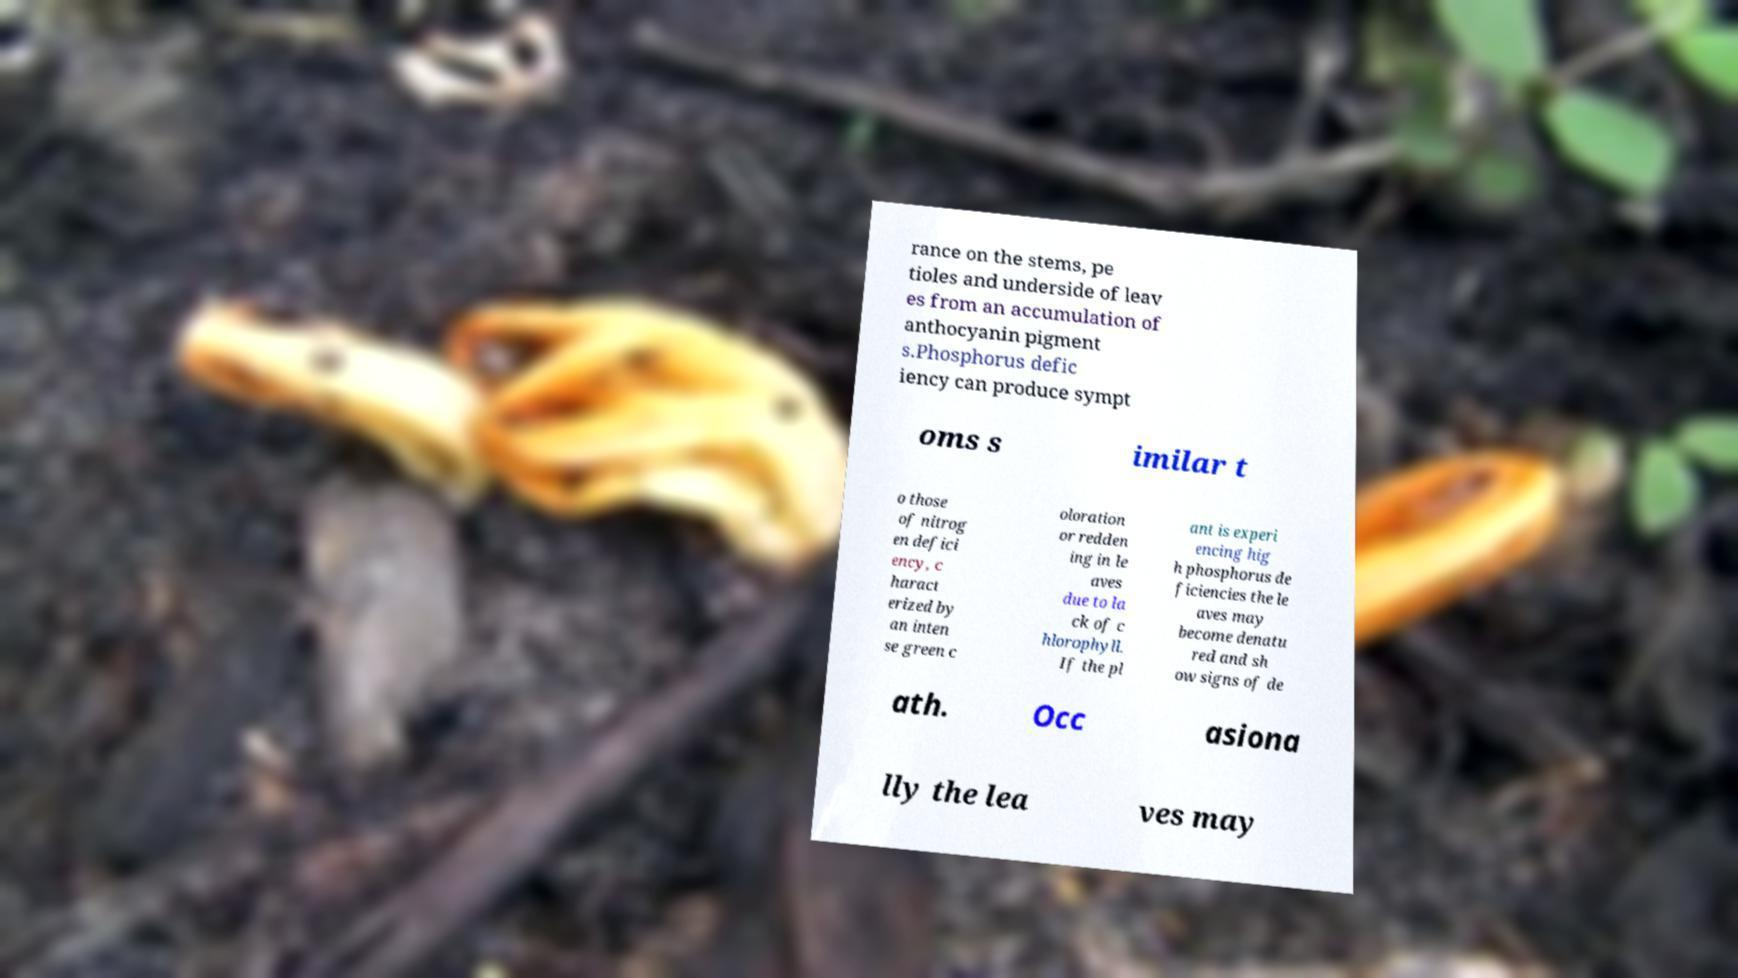There's text embedded in this image that I need extracted. Can you transcribe it verbatim? rance on the stems, pe tioles and underside of leav es from an accumulation of anthocyanin pigment s.Phosphorus defic iency can produce sympt oms s imilar t o those of nitrog en defici ency, c haract erized by an inten se green c oloration or redden ing in le aves due to la ck of c hlorophyll. If the pl ant is experi encing hig h phosphorus de ficiencies the le aves may become denatu red and sh ow signs of de ath. Occ asiona lly the lea ves may 